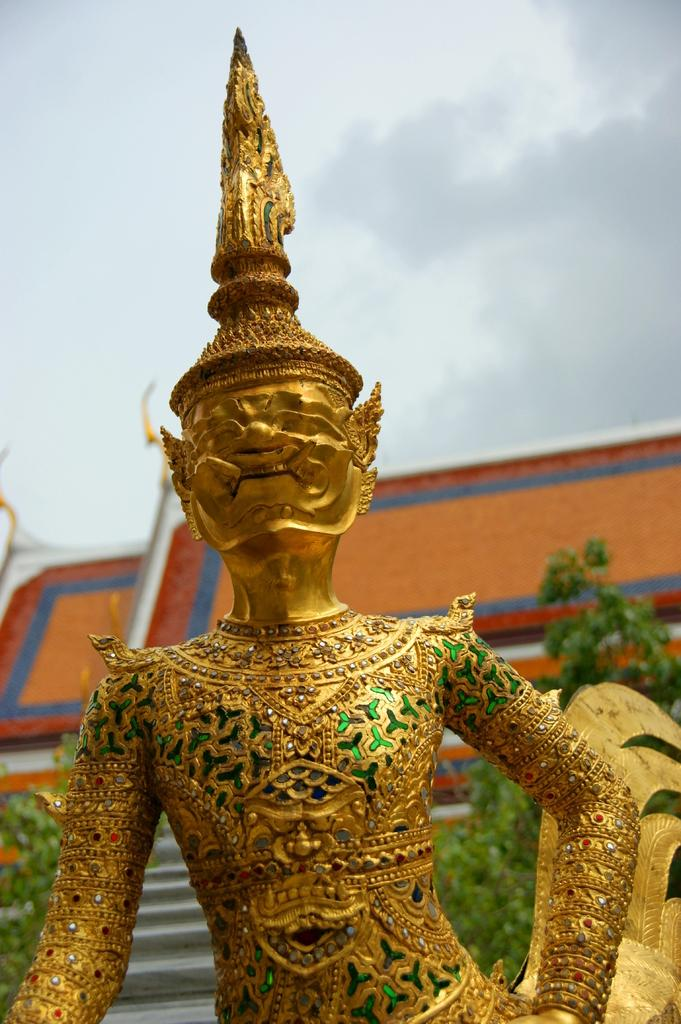What is the main subject of the image? There is a sculpture of a person in the image. What type of natural elements can be seen in the image? There are trees in the image. What type of man-made structure is visible in the image? There appears to be a building in the image. What can be seen in the background of the image? The sky is visible in the background of the image. What type of rhythm can be heard coming from the sculpture in the image? There is no sound or rhythm associated with the sculpture in the image. 